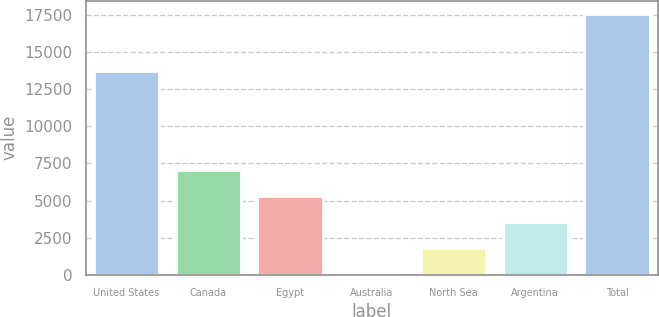Convert chart. <chart><loc_0><loc_0><loc_500><loc_500><bar_chart><fcel>United States<fcel>Canada<fcel>Egypt<fcel>Australia<fcel>North Sea<fcel>Argentina<fcel>Total<nl><fcel>13762<fcel>7072.6<fcel>5316.7<fcel>49<fcel>1804.9<fcel>3560.8<fcel>17608<nl></chart> 